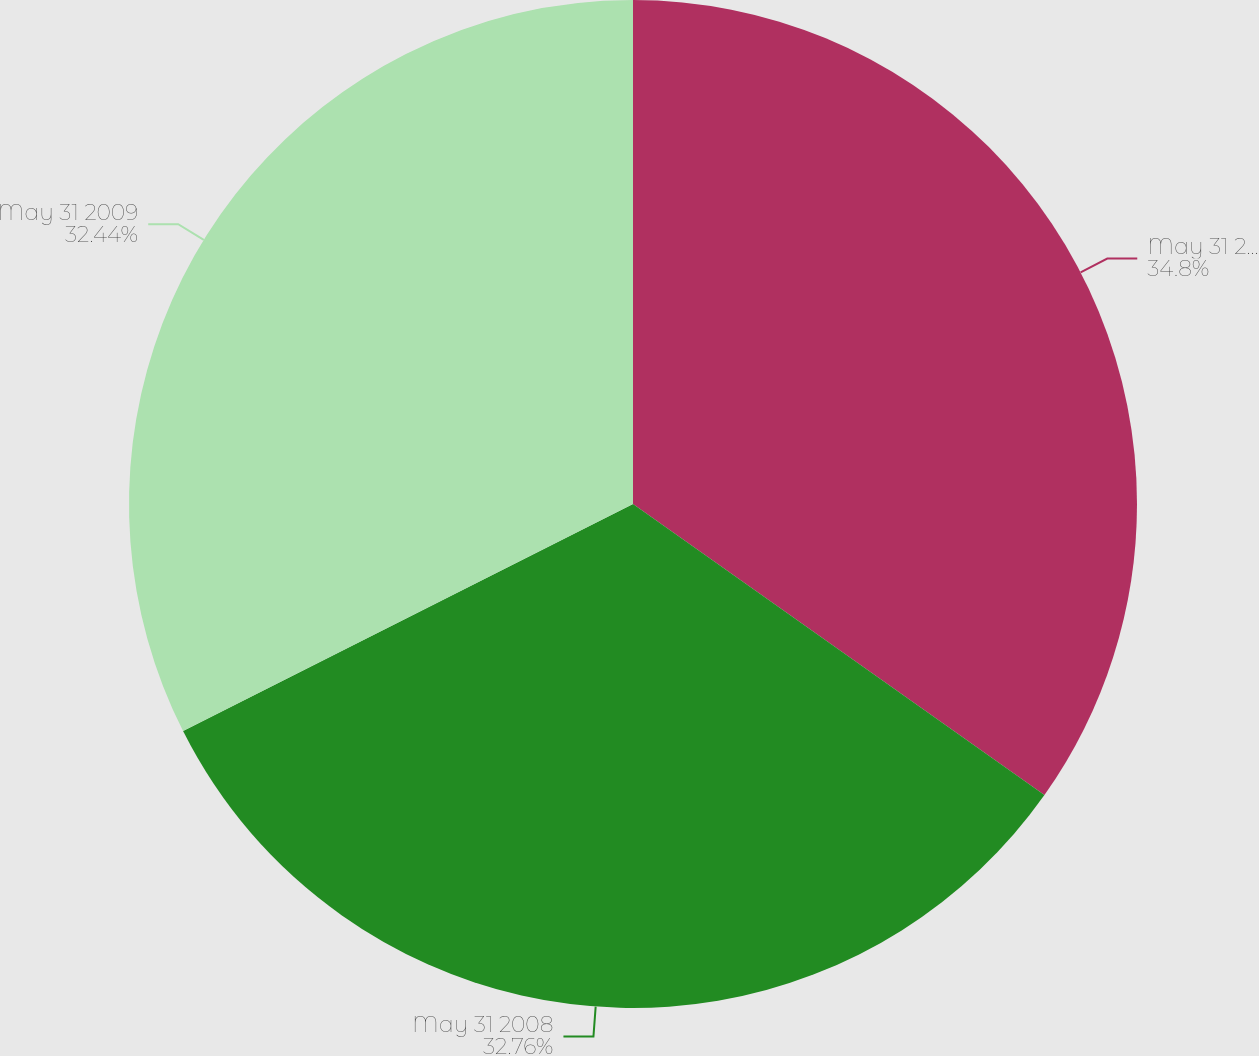Convert chart to OTSL. <chart><loc_0><loc_0><loc_500><loc_500><pie_chart><fcel>May 31 2007<fcel>May 31 2008<fcel>May 31 2009<nl><fcel>34.8%<fcel>32.76%<fcel>32.44%<nl></chart> 